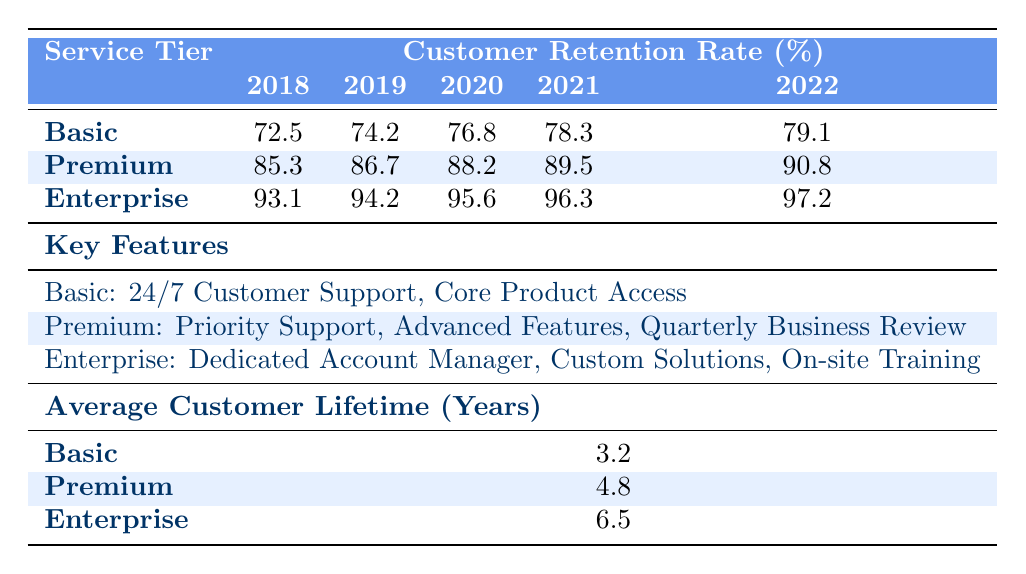What's the customer retention rate for the Premium service tier in 2020? From the table, the retention rate for the Premium service tier in 2020 is listed directly under the corresponding year column. It shows 88.2%.
Answer: 88.2% Which service tier had the highest customer retention rate in 2022? Looking at the table for the year 2022, the retention rates are: Basic (79.1%), Premium (90.8%), and Enterprise (97.2%). The highest rate is for the Enterprise tier at 97.2%.
Answer: Enterprise What is the average customer retention rate for the Basic service tier over the last five years? The retention rates for Basic from 2018 to 2022 are as follows: 72.5%, 74.2%, 76.8%, 78.3%, and 79.1%. To find the average, add these rates: 72.5 + 74.2 + 76.8 + 78.3 + 79.1 = 380.9, then divide by 5. So, the average is 380.9 / 5 = 76.18.
Answer: 76.18 Was the customer retention rate for the Enterprise tier always above 90% in the years represented? Reviewing the table for the Enterprise tier, the retention rates are: 93.1% (2018), 94.2% (2019), 95.6% (2020), 96.3% (2021), and 97.2% (2022). All these values are indeed above 90%.
Answer: Yes How much did the customer retention rate for the Premium service tier increase from 2018 to 2022? The Premium retention rate in 2018 was 85.3% and in 2022 it was 90.8%. To find the increase: 90.8 - 85.3 = 5.5%. Therefore, the retention rate increased by 5.5% over these years.
Answer: 5.5% Which service tier has the longest average customer lifetime? The average customer lifetime corresponds to the values listed for each tier: Basic (3.2 years), Premium (4.8 years), and Enterprise (6.5 years). The longest average is for the Enterprise tier at 6.5 years.
Answer: Enterprise Is it true that the Basic service tier has the lowest retention rate for all years compared to Premium and Enterprise? Checking the retention rates for each service tier over the years, it is evident that the Basic tier has lower rates than both Premium and Enterprise for every year listed (2018-2022).
Answer: Yes What was the retention rate for the Basic service tier in the year that saw the highest rate? The table shows that the highest retention rate for the Basic service tier was in 2022, recorded at 79.1%.
Answer: 79.1% 